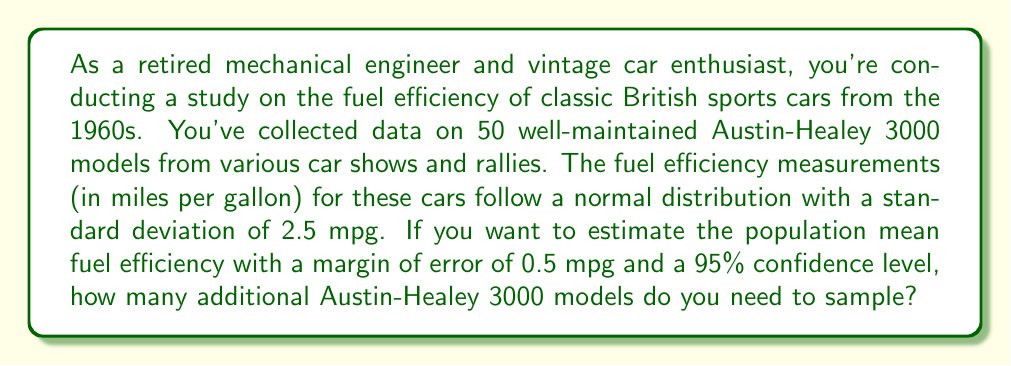Can you solve this math problem? To solve this problem, we'll use the formula for sample size determination in estimating a population mean:

$$n = \left(\frac{z_{\alpha/2} \cdot \sigma}{E}\right)^2$$

Where:
$n$ = required sample size
$z_{\alpha/2}$ = z-score for the desired confidence level
$\sigma$ = population standard deviation
$E$ = margin of error

Given:
- Confidence level = 95% (z-score = 1.96)
- Standard deviation ($\sigma$) = 2.5 mpg
- Margin of error ($E$) = 0.5 mpg

Step 1: Calculate the required sample size.
$$n = \left(\frac{1.96 \cdot 2.5}{0.5}\right)^2 = (4.9)^2 = 24.01 \approx 25$$

Step 2: Determine the number of additional samples needed.
Additional samples = Required sample size - Current sample size
Additional samples = 25 - 50 = -25

Since the result is negative, it means we already have more than enough samples to meet the desired margin of error and confidence level.

Step 3: Conclude that no additional samples are needed.
Answer: No additional Austin-Healey 3000 models need to be sampled. The current sample size of 50 is already sufficient to estimate the population mean fuel efficiency with a margin of error of 0.5 mpg and a 95% confidence level. 